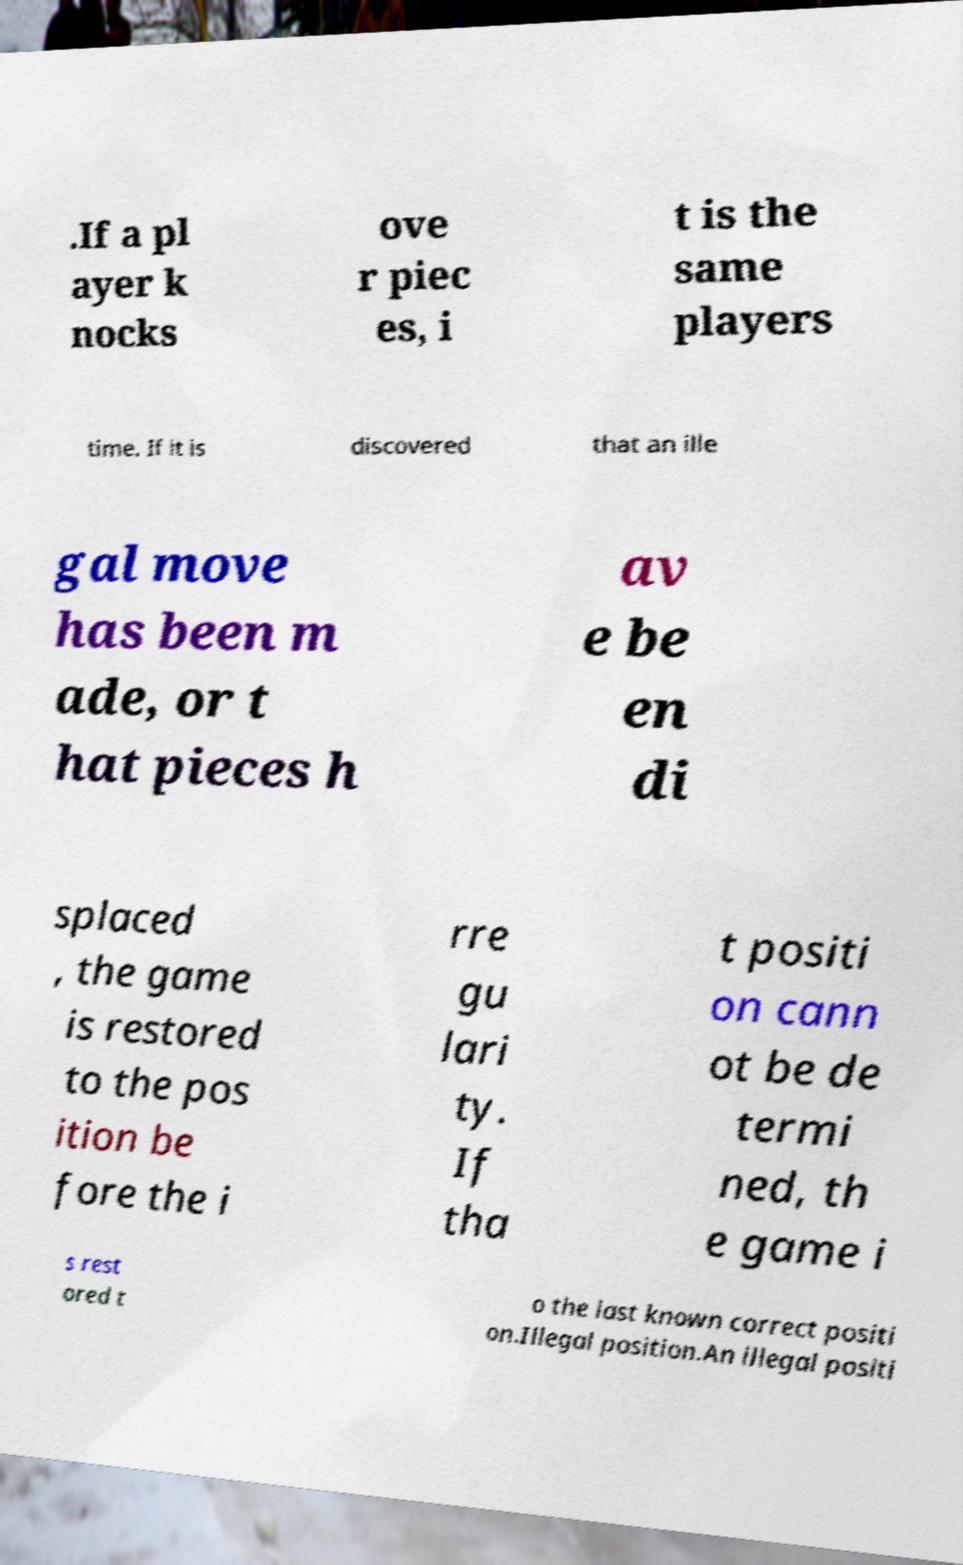Please identify and transcribe the text found in this image. .If a pl ayer k nocks ove r piec es, i t is the same players time. If it is discovered that an ille gal move has been m ade, or t hat pieces h av e be en di splaced , the game is restored to the pos ition be fore the i rre gu lari ty. If tha t positi on cann ot be de termi ned, th e game i s rest ored t o the last known correct positi on.Illegal position.An illegal positi 